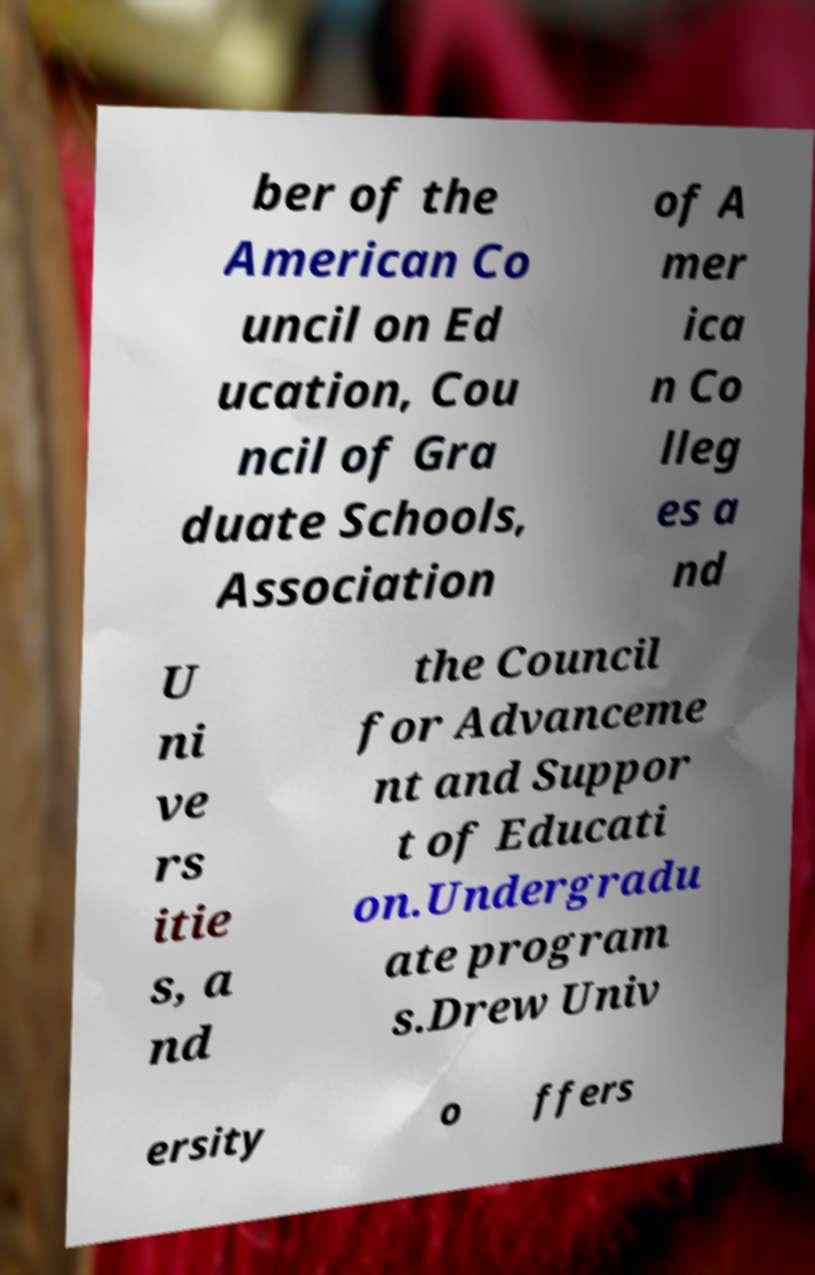Please identify and transcribe the text found in this image. ber of the American Co uncil on Ed ucation, Cou ncil of Gra duate Schools, Association of A mer ica n Co lleg es a nd U ni ve rs itie s, a nd the Council for Advanceme nt and Suppor t of Educati on.Undergradu ate program s.Drew Univ ersity o ffers 